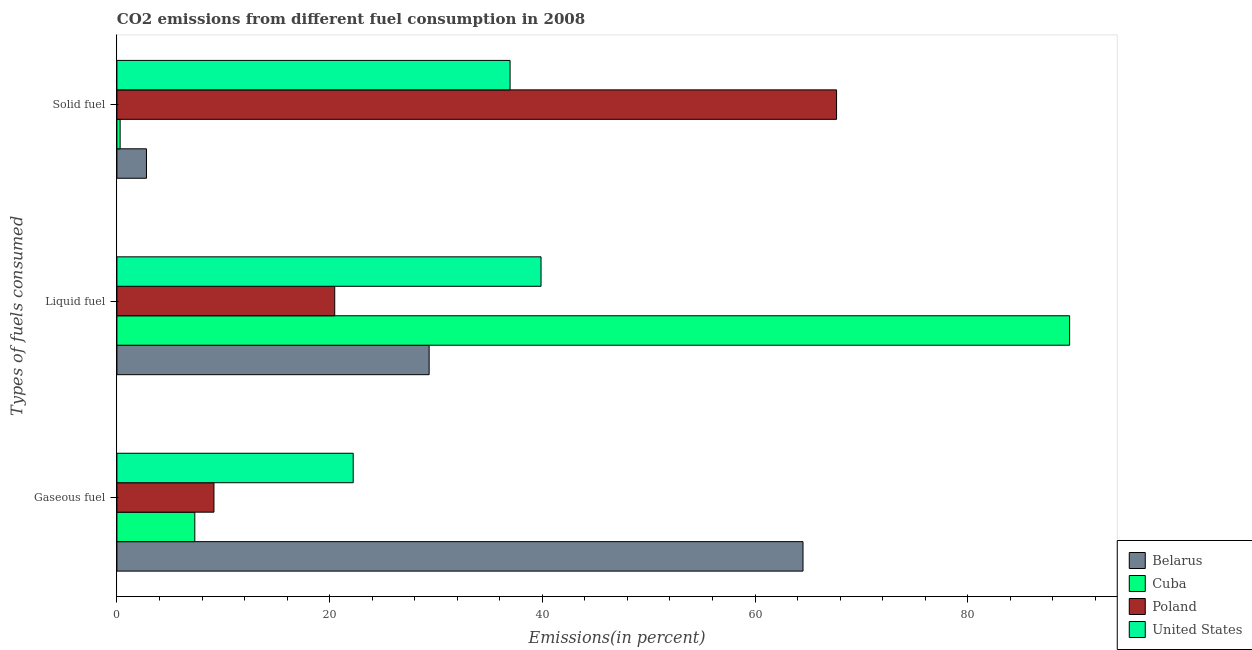How many groups of bars are there?
Offer a very short reply. 3. How many bars are there on the 2nd tick from the top?
Provide a short and direct response. 4. What is the label of the 2nd group of bars from the top?
Your answer should be compact. Liquid fuel. What is the percentage of gaseous fuel emission in Cuba?
Make the answer very short. 7.32. Across all countries, what is the maximum percentage of gaseous fuel emission?
Your response must be concise. 64.51. Across all countries, what is the minimum percentage of solid fuel emission?
Provide a succinct answer. 0.3. In which country was the percentage of liquid fuel emission maximum?
Make the answer very short. Cuba. In which country was the percentage of solid fuel emission minimum?
Give a very brief answer. Cuba. What is the total percentage of liquid fuel emission in the graph?
Keep it short and to the point. 179.3. What is the difference between the percentage of liquid fuel emission in Cuba and that in United States?
Make the answer very short. 49.7. What is the difference between the percentage of solid fuel emission in United States and the percentage of gaseous fuel emission in Cuba?
Make the answer very short. 29.64. What is the average percentage of solid fuel emission per country?
Ensure brevity in your answer.  26.93. What is the difference between the percentage of gaseous fuel emission and percentage of liquid fuel emission in Cuba?
Provide a short and direct response. -82.26. What is the ratio of the percentage of liquid fuel emission in Poland to that in United States?
Your answer should be compact. 0.51. Is the percentage of liquid fuel emission in Cuba less than that in Poland?
Give a very brief answer. No. Is the difference between the percentage of gaseous fuel emission in United States and Cuba greater than the difference between the percentage of liquid fuel emission in United States and Cuba?
Keep it short and to the point. Yes. What is the difference between the highest and the second highest percentage of gaseous fuel emission?
Offer a very short reply. 42.3. What is the difference between the highest and the lowest percentage of gaseous fuel emission?
Ensure brevity in your answer.  57.19. What does the 4th bar from the top in Gaseous fuel represents?
Provide a succinct answer. Belarus. What does the 2nd bar from the bottom in Solid fuel represents?
Your response must be concise. Cuba. How many bars are there?
Make the answer very short. 12. How many countries are there in the graph?
Your response must be concise. 4. What is the difference between two consecutive major ticks on the X-axis?
Ensure brevity in your answer.  20. Does the graph contain any zero values?
Your answer should be compact. No. Does the graph contain grids?
Give a very brief answer. No. Where does the legend appear in the graph?
Give a very brief answer. Bottom right. What is the title of the graph?
Your answer should be very brief. CO2 emissions from different fuel consumption in 2008. Does "Somalia" appear as one of the legend labels in the graph?
Your answer should be very brief. No. What is the label or title of the X-axis?
Give a very brief answer. Emissions(in percent). What is the label or title of the Y-axis?
Your answer should be compact. Types of fuels consumed. What is the Emissions(in percent) in Belarus in Gaseous fuel?
Keep it short and to the point. 64.51. What is the Emissions(in percent) in Cuba in Gaseous fuel?
Your answer should be compact. 7.32. What is the Emissions(in percent) of Poland in Gaseous fuel?
Your answer should be very brief. 9.12. What is the Emissions(in percent) in United States in Gaseous fuel?
Offer a very short reply. 22.22. What is the Emissions(in percent) of Belarus in Liquid fuel?
Provide a short and direct response. 29.36. What is the Emissions(in percent) in Cuba in Liquid fuel?
Provide a succinct answer. 89.58. What is the Emissions(in percent) in Poland in Liquid fuel?
Keep it short and to the point. 20.48. What is the Emissions(in percent) of United States in Liquid fuel?
Your answer should be very brief. 39.88. What is the Emissions(in percent) of Belarus in Solid fuel?
Keep it short and to the point. 2.78. What is the Emissions(in percent) in Cuba in Solid fuel?
Give a very brief answer. 0.3. What is the Emissions(in percent) of Poland in Solid fuel?
Make the answer very short. 67.67. What is the Emissions(in percent) of United States in Solid fuel?
Make the answer very short. 36.97. Across all Types of fuels consumed, what is the maximum Emissions(in percent) in Belarus?
Provide a short and direct response. 64.51. Across all Types of fuels consumed, what is the maximum Emissions(in percent) of Cuba?
Your answer should be compact. 89.58. Across all Types of fuels consumed, what is the maximum Emissions(in percent) in Poland?
Provide a short and direct response. 67.67. Across all Types of fuels consumed, what is the maximum Emissions(in percent) of United States?
Your response must be concise. 39.88. Across all Types of fuels consumed, what is the minimum Emissions(in percent) in Belarus?
Ensure brevity in your answer.  2.78. Across all Types of fuels consumed, what is the minimum Emissions(in percent) in Cuba?
Keep it short and to the point. 0.3. Across all Types of fuels consumed, what is the minimum Emissions(in percent) in Poland?
Provide a succinct answer. 9.12. Across all Types of fuels consumed, what is the minimum Emissions(in percent) of United States?
Keep it short and to the point. 22.22. What is the total Emissions(in percent) in Belarus in the graph?
Your response must be concise. 96.65. What is the total Emissions(in percent) in Cuba in the graph?
Provide a short and direct response. 97.21. What is the total Emissions(in percent) in Poland in the graph?
Your response must be concise. 97.27. What is the total Emissions(in percent) in United States in the graph?
Offer a very short reply. 99.06. What is the difference between the Emissions(in percent) of Belarus in Gaseous fuel and that in Liquid fuel?
Make the answer very short. 35.15. What is the difference between the Emissions(in percent) in Cuba in Gaseous fuel and that in Liquid fuel?
Your answer should be very brief. -82.26. What is the difference between the Emissions(in percent) of Poland in Gaseous fuel and that in Liquid fuel?
Provide a succinct answer. -11.36. What is the difference between the Emissions(in percent) of United States in Gaseous fuel and that in Liquid fuel?
Offer a terse response. -17.66. What is the difference between the Emissions(in percent) of Belarus in Gaseous fuel and that in Solid fuel?
Your answer should be compact. 61.73. What is the difference between the Emissions(in percent) in Cuba in Gaseous fuel and that in Solid fuel?
Make the answer very short. 7.02. What is the difference between the Emissions(in percent) in Poland in Gaseous fuel and that in Solid fuel?
Make the answer very short. -58.54. What is the difference between the Emissions(in percent) in United States in Gaseous fuel and that in Solid fuel?
Your answer should be very brief. -14.75. What is the difference between the Emissions(in percent) of Belarus in Liquid fuel and that in Solid fuel?
Your answer should be very brief. 26.58. What is the difference between the Emissions(in percent) in Cuba in Liquid fuel and that in Solid fuel?
Offer a very short reply. 89.28. What is the difference between the Emissions(in percent) in Poland in Liquid fuel and that in Solid fuel?
Ensure brevity in your answer.  -47.18. What is the difference between the Emissions(in percent) in United States in Liquid fuel and that in Solid fuel?
Provide a succinct answer. 2.91. What is the difference between the Emissions(in percent) of Belarus in Gaseous fuel and the Emissions(in percent) of Cuba in Liquid fuel?
Make the answer very short. -25.07. What is the difference between the Emissions(in percent) in Belarus in Gaseous fuel and the Emissions(in percent) in Poland in Liquid fuel?
Ensure brevity in your answer.  44.03. What is the difference between the Emissions(in percent) of Belarus in Gaseous fuel and the Emissions(in percent) of United States in Liquid fuel?
Ensure brevity in your answer.  24.63. What is the difference between the Emissions(in percent) of Cuba in Gaseous fuel and the Emissions(in percent) of Poland in Liquid fuel?
Provide a succinct answer. -13.16. What is the difference between the Emissions(in percent) in Cuba in Gaseous fuel and the Emissions(in percent) in United States in Liquid fuel?
Offer a very short reply. -32.56. What is the difference between the Emissions(in percent) in Poland in Gaseous fuel and the Emissions(in percent) in United States in Liquid fuel?
Make the answer very short. -30.75. What is the difference between the Emissions(in percent) of Belarus in Gaseous fuel and the Emissions(in percent) of Cuba in Solid fuel?
Your response must be concise. 64.21. What is the difference between the Emissions(in percent) in Belarus in Gaseous fuel and the Emissions(in percent) in Poland in Solid fuel?
Your answer should be very brief. -3.15. What is the difference between the Emissions(in percent) of Belarus in Gaseous fuel and the Emissions(in percent) of United States in Solid fuel?
Give a very brief answer. 27.54. What is the difference between the Emissions(in percent) of Cuba in Gaseous fuel and the Emissions(in percent) of Poland in Solid fuel?
Ensure brevity in your answer.  -60.34. What is the difference between the Emissions(in percent) of Cuba in Gaseous fuel and the Emissions(in percent) of United States in Solid fuel?
Make the answer very short. -29.64. What is the difference between the Emissions(in percent) of Poland in Gaseous fuel and the Emissions(in percent) of United States in Solid fuel?
Make the answer very short. -27.84. What is the difference between the Emissions(in percent) in Belarus in Liquid fuel and the Emissions(in percent) in Cuba in Solid fuel?
Ensure brevity in your answer.  29.06. What is the difference between the Emissions(in percent) in Belarus in Liquid fuel and the Emissions(in percent) in Poland in Solid fuel?
Provide a succinct answer. -38.31. What is the difference between the Emissions(in percent) in Belarus in Liquid fuel and the Emissions(in percent) in United States in Solid fuel?
Make the answer very short. -7.61. What is the difference between the Emissions(in percent) in Cuba in Liquid fuel and the Emissions(in percent) in Poland in Solid fuel?
Provide a succinct answer. 21.91. What is the difference between the Emissions(in percent) in Cuba in Liquid fuel and the Emissions(in percent) in United States in Solid fuel?
Provide a short and direct response. 52.61. What is the difference between the Emissions(in percent) in Poland in Liquid fuel and the Emissions(in percent) in United States in Solid fuel?
Your answer should be compact. -16.49. What is the average Emissions(in percent) of Belarus per Types of fuels consumed?
Your answer should be compact. 32.22. What is the average Emissions(in percent) in Cuba per Types of fuels consumed?
Your answer should be compact. 32.4. What is the average Emissions(in percent) of Poland per Types of fuels consumed?
Offer a terse response. 32.42. What is the average Emissions(in percent) in United States per Types of fuels consumed?
Your answer should be very brief. 33.02. What is the difference between the Emissions(in percent) in Belarus and Emissions(in percent) in Cuba in Gaseous fuel?
Your answer should be compact. 57.19. What is the difference between the Emissions(in percent) in Belarus and Emissions(in percent) in Poland in Gaseous fuel?
Offer a terse response. 55.39. What is the difference between the Emissions(in percent) of Belarus and Emissions(in percent) of United States in Gaseous fuel?
Your response must be concise. 42.3. What is the difference between the Emissions(in percent) of Cuba and Emissions(in percent) of Poland in Gaseous fuel?
Offer a terse response. -1.8. What is the difference between the Emissions(in percent) of Cuba and Emissions(in percent) of United States in Gaseous fuel?
Offer a very short reply. -14.89. What is the difference between the Emissions(in percent) of Poland and Emissions(in percent) of United States in Gaseous fuel?
Make the answer very short. -13.09. What is the difference between the Emissions(in percent) of Belarus and Emissions(in percent) of Cuba in Liquid fuel?
Your answer should be very brief. -60.22. What is the difference between the Emissions(in percent) in Belarus and Emissions(in percent) in Poland in Liquid fuel?
Keep it short and to the point. 8.88. What is the difference between the Emissions(in percent) in Belarus and Emissions(in percent) in United States in Liquid fuel?
Offer a very short reply. -10.52. What is the difference between the Emissions(in percent) in Cuba and Emissions(in percent) in Poland in Liquid fuel?
Offer a very short reply. 69.1. What is the difference between the Emissions(in percent) of Cuba and Emissions(in percent) of United States in Liquid fuel?
Offer a terse response. 49.7. What is the difference between the Emissions(in percent) in Poland and Emissions(in percent) in United States in Liquid fuel?
Ensure brevity in your answer.  -19.4. What is the difference between the Emissions(in percent) of Belarus and Emissions(in percent) of Cuba in Solid fuel?
Keep it short and to the point. 2.48. What is the difference between the Emissions(in percent) of Belarus and Emissions(in percent) of Poland in Solid fuel?
Your response must be concise. -64.89. What is the difference between the Emissions(in percent) in Belarus and Emissions(in percent) in United States in Solid fuel?
Your answer should be compact. -34.19. What is the difference between the Emissions(in percent) in Cuba and Emissions(in percent) in Poland in Solid fuel?
Provide a short and direct response. -67.36. What is the difference between the Emissions(in percent) in Cuba and Emissions(in percent) in United States in Solid fuel?
Your response must be concise. -36.67. What is the difference between the Emissions(in percent) in Poland and Emissions(in percent) in United States in Solid fuel?
Your answer should be very brief. 30.7. What is the ratio of the Emissions(in percent) of Belarus in Gaseous fuel to that in Liquid fuel?
Your answer should be very brief. 2.2. What is the ratio of the Emissions(in percent) in Cuba in Gaseous fuel to that in Liquid fuel?
Your response must be concise. 0.08. What is the ratio of the Emissions(in percent) of Poland in Gaseous fuel to that in Liquid fuel?
Your response must be concise. 0.45. What is the ratio of the Emissions(in percent) in United States in Gaseous fuel to that in Liquid fuel?
Your response must be concise. 0.56. What is the ratio of the Emissions(in percent) in Belarus in Gaseous fuel to that in Solid fuel?
Give a very brief answer. 23.22. What is the ratio of the Emissions(in percent) in Cuba in Gaseous fuel to that in Solid fuel?
Give a very brief answer. 24.32. What is the ratio of the Emissions(in percent) in Poland in Gaseous fuel to that in Solid fuel?
Your answer should be compact. 0.13. What is the ratio of the Emissions(in percent) of United States in Gaseous fuel to that in Solid fuel?
Give a very brief answer. 0.6. What is the ratio of the Emissions(in percent) in Belarus in Liquid fuel to that in Solid fuel?
Provide a short and direct response. 10.57. What is the ratio of the Emissions(in percent) in Cuba in Liquid fuel to that in Solid fuel?
Your response must be concise. 297.48. What is the ratio of the Emissions(in percent) in Poland in Liquid fuel to that in Solid fuel?
Your answer should be compact. 0.3. What is the ratio of the Emissions(in percent) of United States in Liquid fuel to that in Solid fuel?
Your answer should be compact. 1.08. What is the difference between the highest and the second highest Emissions(in percent) of Belarus?
Your answer should be compact. 35.15. What is the difference between the highest and the second highest Emissions(in percent) of Cuba?
Your response must be concise. 82.26. What is the difference between the highest and the second highest Emissions(in percent) in Poland?
Your answer should be very brief. 47.18. What is the difference between the highest and the second highest Emissions(in percent) in United States?
Provide a succinct answer. 2.91. What is the difference between the highest and the lowest Emissions(in percent) in Belarus?
Your response must be concise. 61.73. What is the difference between the highest and the lowest Emissions(in percent) in Cuba?
Keep it short and to the point. 89.28. What is the difference between the highest and the lowest Emissions(in percent) of Poland?
Provide a short and direct response. 58.54. What is the difference between the highest and the lowest Emissions(in percent) in United States?
Make the answer very short. 17.66. 